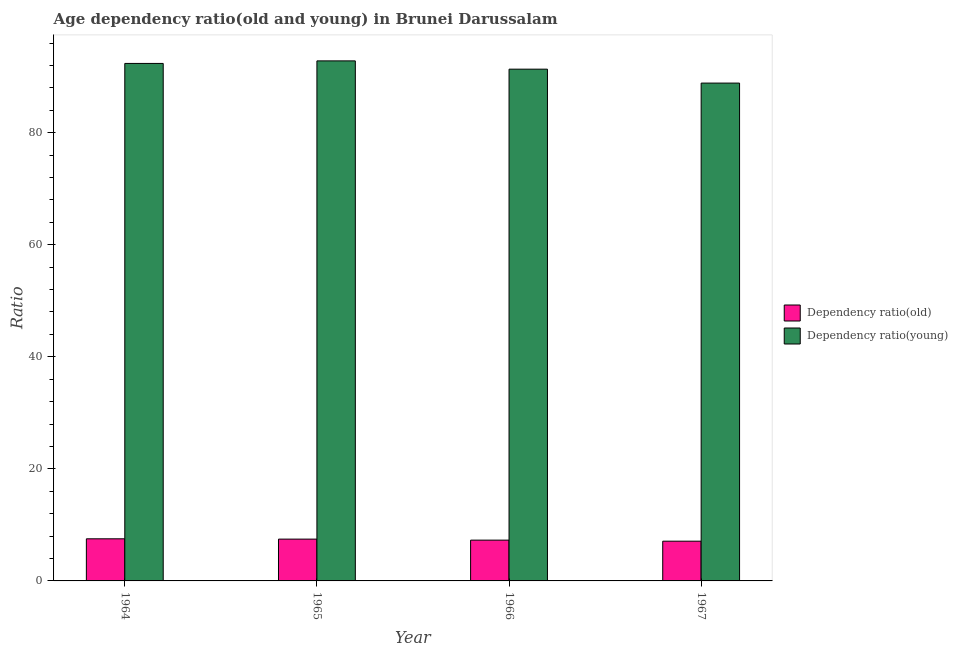How many different coloured bars are there?
Your answer should be very brief. 2. Are the number of bars per tick equal to the number of legend labels?
Keep it short and to the point. Yes. Are the number of bars on each tick of the X-axis equal?
Offer a terse response. Yes. How many bars are there on the 3rd tick from the left?
Ensure brevity in your answer.  2. What is the label of the 3rd group of bars from the left?
Offer a very short reply. 1966. What is the age dependency ratio(old) in 1966?
Provide a short and direct response. 7.28. Across all years, what is the maximum age dependency ratio(young)?
Ensure brevity in your answer.  92.81. Across all years, what is the minimum age dependency ratio(young)?
Your response must be concise. 88.85. In which year was the age dependency ratio(young) maximum?
Make the answer very short. 1965. In which year was the age dependency ratio(young) minimum?
Your answer should be compact. 1967. What is the total age dependency ratio(old) in the graph?
Ensure brevity in your answer.  29.35. What is the difference between the age dependency ratio(old) in 1964 and that in 1966?
Offer a terse response. 0.24. What is the difference between the age dependency ratio(old) in 1966 and the age dependency ratio(young) in 1967?
Keep it short and to the point. 0.19. What is the average age dependency ratio(old) per year?
Offer a terse response. 7.34. In how many years, is the age dependency ratio(old) greater than 48?
Ensure brevity in your answer.  0. What is the ratio of the age dependency ratio(young) in 1965 to that in 1967?
Provide a succinct answer. 1.04. Is the age dependency ratio(young) in 1964 less than that in 1965?
Provide a short and direct response. Yes. Is the difference between the age dependency ratio(old) in 1966 and 1967 greater than the difference between the age dependency ratio(young) in 1966 and 1967?
Offer a very short reply. No. What is the difference between the highest and the second highest age dependency ratio(young)?
Offer a terse response. 0.45. What is the difference between the highest and the lowest age dependency ratio(young)?
Keep it short and to the point. 3.97. In how many years, is the age dependency ratio(old) greater than the average age dependency ratio(old) taken over all years?
Your answer should be very brief. 2. What does the 1st bar from the left in 1967 represents?
Offer a very short reply. Dependency ratio(old). What does the 2nd bar from the right in 1967 represents?
Ensure brevity in your answer.  Dependency ratio(old). How many bars are there?
Your answer should be very brief. 8. Are all the bars in the graph horizontal?
Make the answer very short. No. What is the difference between two consecutive major ticks on the Y-axis?
Your answer should be very brief. 20. Are the values on the major ticks of Y-axis written in scientific E-notation?
Keep it short and to the point. No. Does the graph contain grids?
Your answer should be very brief. No. How many legend labels are there?
Your answer should be very brief. 2. What is the title of the graph?
Your answer should be very brief. Age dependency ratio(old and young) in Brunei Darussalam. What is the label or title of the Y-axis?
Make the answer very short. Ratio. What is the Ratio in Dependency ratio(old) in 1964?
Your answer should be compact. 7.52. What is the Ratio in Dependency ratio(young) in 1964?
Provide a short and direct response. 92.36. What is the Ratio of Dependency ratio(old) in 1965?
Your answer should be compact. 7.46. What is the Ratio of Dependency ratio(young) in 1965?
Your response must be concise. 92.81. What is the Ratio in Dependency ratio(old) in 1966?
Provide a short and direct response. 7.28. What is the Ratio in Dependency ratio(young) in 1966?
Your response must be concise. 91.33. What is the Ratio in Dependency ratio(old) in 1967?
Offer a very short reply. 7.09. What is the Ratio of Dependency ratio(young) in 1967?
Your answer should be very brief. 88.85. Across all years, what is the maximum Ratio of Dependency ratio(old)?
Provide a short and direct response. 7.52. Across all years, what is the maximum Ratio of Dependency ratio(young)?
Offer a very short reply. 92.81. Across all years, what is the minimum Ratio of Dependency ratio(old)?
Offer a very short reply. 7.09. Across all years, what is the minimum Ratio in Dependency ratio(young)?
Provide a short and direct response. 88.85. What is the total Ratio in Dependency ratio(old) in the graph?
Your response must be concise. 29.35. What is the total Ratio in Dependency ratio(young) in the graph?
Provide a succinct answer. 365.35. What is the difference between the Ratio of Dependency ratio(old) in 1964 and that in 1965?
Your answer should be compact. 0.05. What is the difference between the Ratio in Dependency ratio(young) in 1964 and that in 1965?
Ensure brevity in your answer.  -0.45. What is the difference between the Ratio of Dependency ratio(old) in 1964 and that in 1966?
Offer a terse response. 0.24. What is the difference between the Ratio of Dependency ratio(young) in 1964 and that in 1966?
Give a very brief answer. 1.02. What is the difference between the Ratio in Dependency ratio(old) in 1964 and that in 1967?
Offer a very short reply. 0.42. What is the difference between the Ratio in Dependency ratio(young) in 1964 and that in 1967?
Provide a short and direct response. 3.51. What is the difference between the Ratio of Dependency ratio(old) in 1965 and that in 1966?
Provide a succinct answer. 0.18. What is the difference between the Ratio in Dependency ratio(young) in 1965 and that in 1966?
Your response must be concise. 1.48. What is the difference between the Ratio in Dependency ratio(old) in 1965 and that in 1967?
Provide a short and direct response. 0.37. What is the difference between the Ratio in Dependency ratio(young) in 1965 and that in 1967?
Keep it short and to the point. 3.96. What is the difference between the Ratio of Dependency ratio(old) in 1966 and that in 1967?
Keep it short and to the point. 0.19. What is the difference between the Ratio of Dependency ratio(young) in 1966 and that in 1967?
Make the answer very short. 2.49. What is the difference between the Ratio of Dependency ratio(old) in 1964 and the Ratio of Dependency ratio(young) in 1965?
Your answer should be compact. -85.3. What is the difference between the Ratio of Dependency ratio(old) in 1964 and the Ratio of Dependency ratio(young) in 1966?
Offer a terse response. -83.82. What is the difference between the Ratio in Dependency ratio(old) in 1964 and the Ratio in Dependency ratio(young) in 1967?
Provide a succinct answer. -81.33. What is the difference between the Ratio in Dependency ratio(old) in 1965 and the Ratio in Dependency ratio(young) in 1966?
Keep it short and to the point. -83.87. What is the difference between the Ratio of Dependency ratio(old) in 1965 and the Ratio of Dependency ratio(young) in 1967?
Ensure brevity in your answer.  -81.39. What is the difference between the Ratio of Dependency ratio(old) in 1966 and the Ratio of Dependency ratio(young) in 1967?
Make the answer very short. -81.57. What is the average Ratio of Dependency ratio(old) per year?
Provide a short and direct response. 7.34. What is the average Ratio in Dependency ratio(young) per year?
Offer a very short reply. 91.34. In the year 1964, what is the difference between the Ratio of Dependency ratio(old) and Ratio of Dependency ratio(young)?
Provide a succinct answer. -84.84. In the year 1965, what is the difference between the Ratio in Dependency ratio(old) and Ratio in Dependency ratio(young)?
Your answer should be compact. -85.35. In the year 1966, what is the difference between the Ratio in Dependency ratio(old) and Ratio in Dependency ratio(young)?
Make the answer very short. -84.06. In the year 1967, what is the difference between the Ratio in Dependency ratio(old) and Ratio in Dependency ratio(young)?
Offer a very short reply. -81.76. What is the ratio of the Ratio of Dependency ratio(old) in 1964 to that in 1965?
Your response must be concise. 1.01. What is the ratio of the Ratio in Dependency ratio(young) in 1964 to that in 1965?
Offer a terse response. 1. What is the ratio of the Ratio in Dependency ratio(old) in 1964 to that in 1966?
Ensure brevity in your answer.  1.03. What is the ratio of the Ratio of Dependency ratio(young) in 1964 to that in 1966?
Provide a short and direct response. 1.01. What is the ratio of the Ratio in Dependency ratio(old) in 1964 to that in 1967?
Provide a succinct answer. 1.06. What is the ratio of the Ratio in Dependency ratio(young) in 1964 to that in 1967?
Your answer should be very brief. 1.04. What is the ratio of the Ratio in Dependency ratio(old) in 1965 to that in 1966?
Your response must be concise. 1.03. What is the ratio of the Ratio in Dependency ratio(young) in 1965 to that in 1966?
Ensure brevity in your answer.  1.02. What is the ratio of the Ratio in Dependency ratio(old) in 1965 to that in 1967?
Provide a short and direct response. 1.05. What is the ratio of the Ratio of Dependency ratio(young) in 1965 to that in 1967?
Keep it short and to the point. 1.04. What is the ratio of the Ratio of Dependency ratio(old) in 1966 to that in 1967?
Ensure brevity in your answer.  1.03. What is the ratio of the Ratio of Dependency ratio(young) in 1966 to that in 1967?
Your response must be concise. 1.03. What is the difference between the highest and the second highest Ratio in Dependency ratio(old)?
Your answer should be very brief. 0.05. What is the difference between the highest and the second highest Ratio in Dependency ratio(young)?
Provide a short and direct response. 0.45. What is the difference between the highest and the lowest Ratio of Dependency ratio(old)?
Your answer should be compact. 0.42. What is the difference between the highest and the lowest Ratio of Dependency ratio(young)?
Your response must be concise. 3.96. 